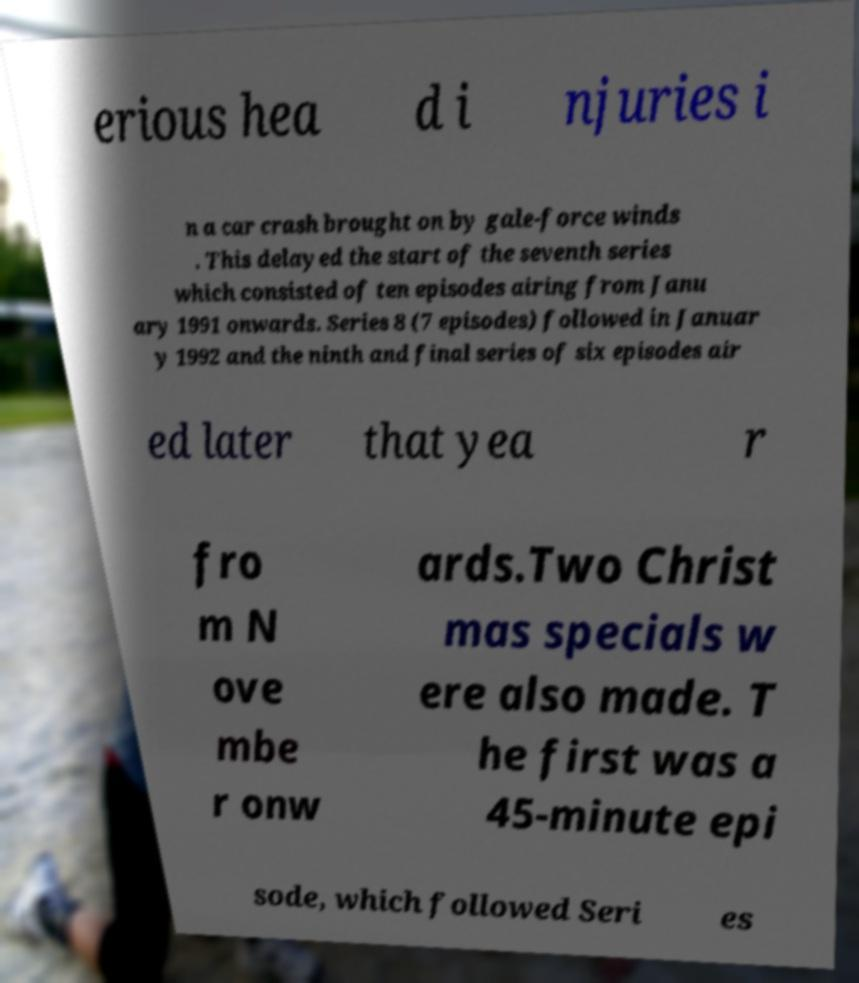Please read and relay the text visible in this image. What does it say? erious hea d i njuries i n a car crash brought on by gale-force winds . This delayed the start of the seventh series which consisted of ten episodes airing from Janu ary 1991 onwards. Series 8 (7 episodes) followed in Januar y 1992 and the ninth and final series of six episodes air ed later that yea r fro m N ove mbe r onw ards.Two Christ mas specials w ere also made. T he first was a 45-minute epi sode, which followed Seri es 